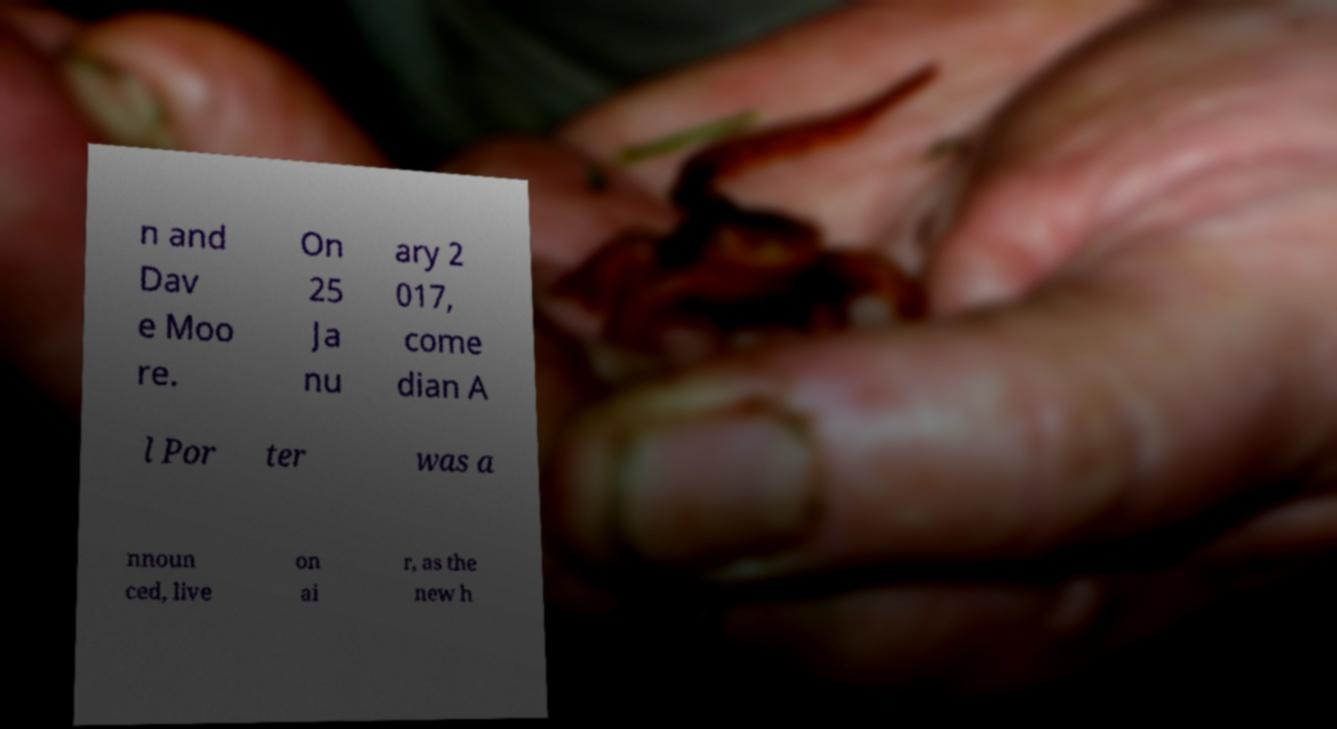Could you assist in decoding the text presented in this image and type it out clearly? n and Dav e Moo re. On 25 Ja nu ary 2 017, come dian A l Por ter was a nnoun ced, live on ai r, as the new h 